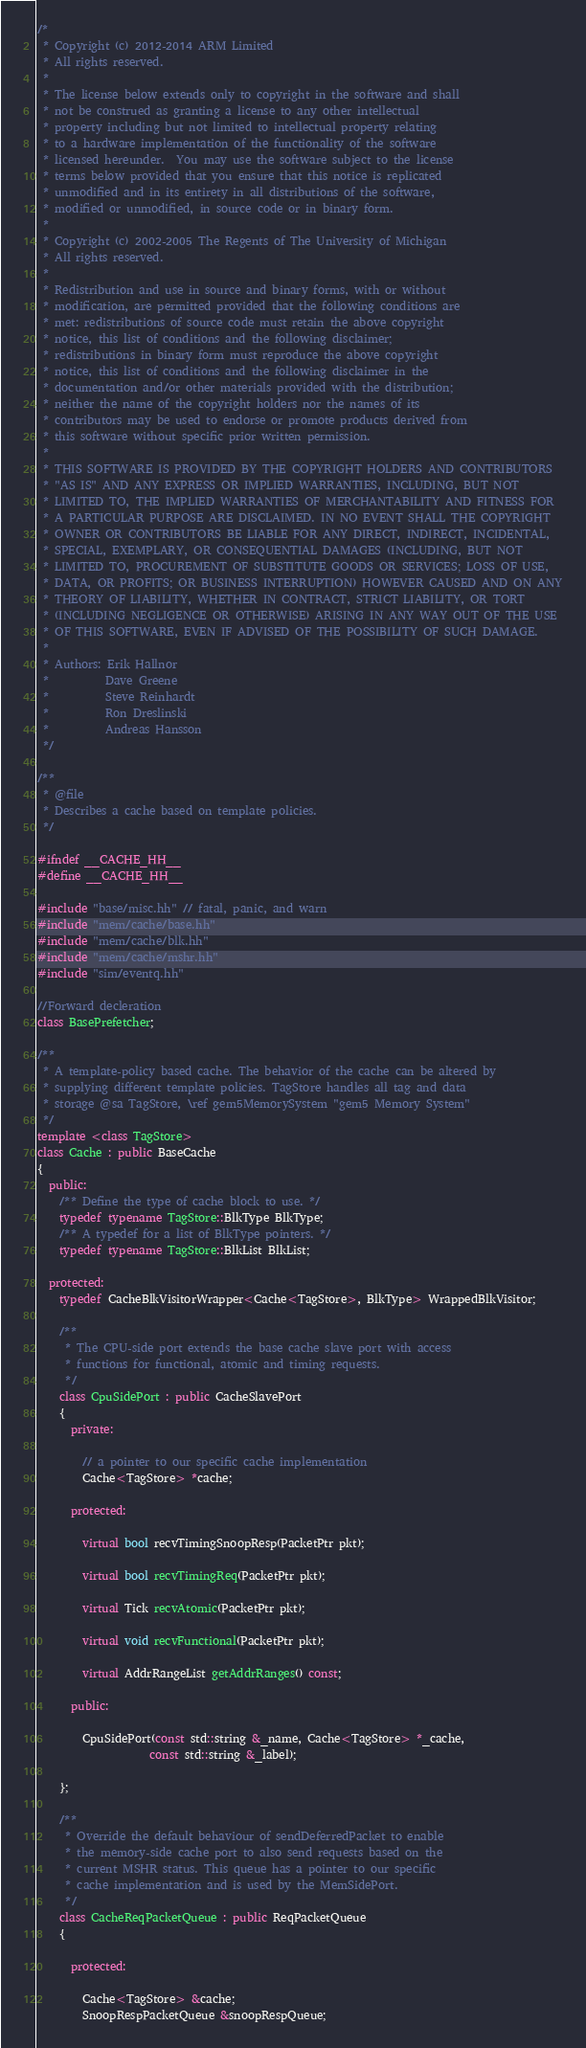Convert code to text. <code><loc_0><loc_0><loc_500><loc_500><_C++_>/*
 * Copyright (c) 2012-2014 ARM Limited
 * All rights reserved.
 *
 * The license below extends only to copyright in the software and shall
 * not be construed as granting a license to any other intellectual
 * property including but not limited to intellectual property relating
 * to a hardware implementation of the functionality of the software
 * licensed hereunder.  You may use the software subject to the license
 * terms below provided that you ensure that this notice is replicated
 * unmodified and in its entirety in all distributions of the software,
 * modified or unmodified, in source code or in binary form.
 *
 * Copyright (c) 2002-2005 The Regents of The University of Michigan
 * All rights reserved.
 *
 * Redistribution and use in source and binary forms, with or without
 * modification, are permitted provided that the following conditions are
 * met: redistributions of source code must retain the above copyright
 * notice, this list of conditions and the following disclaimer;
 * redistributions in binary form must reproduce the above copyright
 * notice, this list of conditions and the following disclaimer in the
 * documentation and/or other materials provided with the distribution;
 * neither the name of the copyright holders nor the names of its
 * contributors may be used to endorse or promote products derived from
 * this software without specific prior written permission.
 *
 * THIS SOFTWARE IS PROVIDED BY THE COPYRIGHT HOLDERS AND CONTRIBUTORS
 * "AS IS" AND ANY EXPRESS OR IMPLIED WARRANTIES, INCLUDING, BUT NOT
 * LIMITED TO, THE IMPLIED WARRANTIES OF MERCHANTABILITY AND FITNESS FOR
 * A PARTICULAR PURPOSE ARE DISCLAIMED. IN NO EVENT SHALL THE COPYRIGHT
 * OWNER OR CONTRIBUTORS BE LIABLE FOR ANY DIRECT, INDIRECT, INCIDENTAL,
 * SPECIAL, EXEMPLARY, OR CONSEQUENTIAL DAMAGES (INCLUDING, BUT NOT
 * LIMITED TO, PROCUREMENT OF SUBSTITUTE GOODS OR SERVICES; LOSS OF USE,
 * DATA, OR PROFITS; OR BUSINESS INTERRUPTION) HOWEVER CAUSED AND ON ANY
 * THEORY OF LIABILITY, WHETHER IN CONTRACT, STRICT LIABILITY, OR TORT
 * (INCLUDING NEGLIGENCE OR OTHERWISE) ARISING IN ANY WAY OUT OF THE USE
 * OF THIS SOFTWARE, EVEN IF ADVISED OF THE POSSIBILITY OF SUCH DAMAGE.
 *
 * Authors: Erik Hallnor
 *          Dave Greene
 *          Steve Reinhardt
 *          Ron Dreslinski
 *          Andreas Hansson
 */

/**
 * @file
 * Describes a cache based on template policies.
 */

#ifndef __CACHE_HH__
#define __CACHE_HH__

#include "base/misc.hh" // fatal, panic, and warn
#include "mem/cache/base.hh"
#include "mem/cache/blk.hh"
#include "mem/cache/mshr.hh"
#include "sim/eventq.hh"

//Forward decleration
class BasePrefetcher;

/**
 * A template-policy based cache. The behavior of the cache can be altered by
 * supplying different template policies. TagStore handles all tag and data
 * storage @sa TagStore, \ref gem5MemorySystem "gem5 Memory System"
 */
template <class TagStore>
class Cache : public BaseCache
{
  public:
    /** Define the type of cache block to use. */
    typedef typename TagStore::BlkType BlkType;
    /** A typedef for a list of BlkType pointers. */
    typedef typename TagStore::BlkList BlkList;

  protected:
    typedef CacheBlkVisitorWrapper<Cache<TagStore>, BlkType> WrappedBlkVisitor;

    /**
     * The CPU-side port extends the base cache slave port with access
     * functions for functional, atomic and timing requests.
     */
    class CpuSidePort : public CacheSlavePort
    {
      private:

        // a pointer to our specific cache implementation
        Cache<TagStore> *cache;

      protected:

        virtual bool recvTimingSnoopResp(PacketPtr pkt);

        virtual bool recvTimingReq(PacketPtr pkt);

        virtual Tick recvAtomic(PacketPtr pkt);

        virtual void recvFunctional(PacketPtr pkt);

        virtual AddrRangeList getAddrRanges() const;

      public:

        CpuSidePort(const std::string &_name, Cache<TagStore> *_cache,
                    const std::string &_label);

    };

    /**
     * Override the default behaviour of sendDeferredPacket to enable
     * the memory-side cache port to also send requests based on the
     * current MSHR status. This queue has a pointer to our specific
     * cache implementation and is used by the MemSidePort.
     */
    class CacheReqPacketQueue : public ReqPacketQueue
    {

      protected:

        Cache<TagStore> &cache;
        SnoopRespPacketQueue &snoopRespQueue;
</code> 